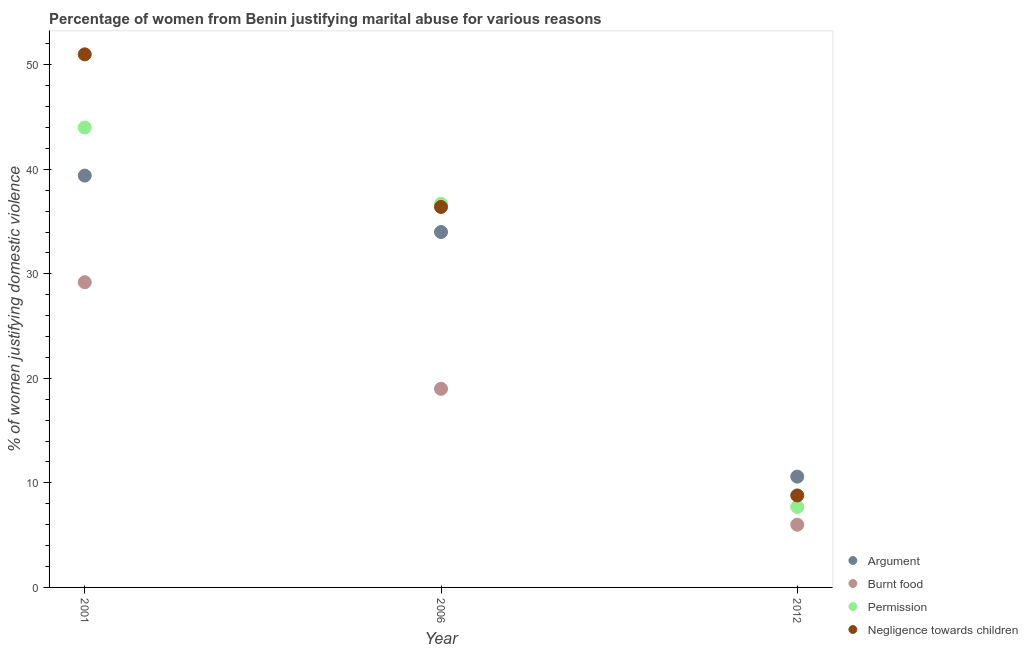Is the number of dotlines equal to the number of legend labels?
Your answer should be compact. Yes. What is the percentage of women justifying abuse for burning food in 2006?
Make the answer very short. 19. Across all years, what is the maximum percentage of women justifying abuse in the case of an argument?
Provide a succinct answer. 39.4. In which year was the percentage of women justifying abuse for going without permission maximum?
Keep it short and to the point. 2001. What is the total percentage of women justifying abuse in the case of an argument in the graph?
Ensure brevity in your answer.  84. What is the difference between the percentage of women justifying abuse in the case of an argument in 2001 and that in 2006?
Your response must be concise. 5.4. What is the difference between the percentage of women justifying abuse for showing negligence towards children in 2001 and the percentage of women justifying abuse in the case of an argument in 2012?
Give a very brief answer. 40.4. What is the average percentage of women justifying abuse for burning food per year?
Offer a very short reply. 18.07. In the year 2001, what is the difference between the percentage of women justifying abuse in the case of an argument and percentage of women justifying abuse for showing negligence towards children?
Provide a short and direct response. -11.6. What is the ratio of the percentage of women justifying abuse for going without permission in 2001 to that in 2006?
Provide a succinct answer. 1.2. What is the difference between the highest and the second highest percentage of women justifying abuse in the case of an argument?
Make the answer very short. 5.4. What is the difference between the highest and the lowest percentage of women justifying abuse for burning food?
Make the answer very short. 23.2. In how many years, is the percentage of women justifying abuse for showing negligence towards children greater than the average percentage of women justifying abuse for showing negligence towards children taken over all years?
Ensure brevity in your answer.  2. Is it the case that in every year, the sum of the percentage of women justifying abuse in the case of an argument and percentage of women justifying abuse for burning food is greater than the percentage of women justifying abuse for going without permission?
Give a very brief answer. Yes. Does the percentage of women justifying abuse for showing negligence towards children monotonically increase over the years?
Provide a succinct answer. No. Is the percentage of women justifying abuse for burning food strictly less than the percentage of women justifying abuse in the case of an argument over the years?
Give a very brief answer. Yes. How many years are there in the graph?
Make the answer very short. 3. What is the difference between two consecutive major ticks on the Y-axis?
Give a very brief answer. 10. Are the values on the major ticks of Y-axis written in scientific E-notation?
Ensure brevity in your answer.  No. How are the legend labels stacked?
Provide a succinct answer. Vertical. What is the title of the graph?
Your response must be concise. Percentage of women from Benin justifying marital abuse for various reasons. What is the label or title of the X-axis?
Offer a terse response. Year. What is the label or title of the Y-axis?
Offer a very short reply. % of women justifying domestic violence. What is the % of women justifying domestic violence in Argument in 2001?
Your response must be concise. 39.4. What is the % of women justifying domestic violence of Burnt food in 2001?
Give a very brief answer. 29.2. What is the % of women justifying domestic violence in Argument in 2006?
Offer a very short reply. 34. What is the % of women justifying domestic violence in Burnt food in 2006?
Provide a short and direct response. 19. What is the % of women justifying domestic violence of Permission in 2006?
Make the answer very short. 36.7. What is the % of women justifying domestic violence of Negligence towards children in 2006?
Ensure brevity in your answer.  36.4. Across all years, what is the maximum % of women justifying domestic violence in Argument?
Keep it short and to the point. 39.4. Across all years, what is the maximum % of women justifying domestic violence of Burnt food?
Offer a terse response. 29.2. Across all years, what is the maximum % of women justifying domestic violence of Negligence towards children?
Provide a succinct answer. 51. Across all years, what is the minimum % of women justifying domestic violence in Argument?
Keep it short and to the point. 10.6. Across all years, what is the minimum % of women justifying domestic violence of Burnt food?
Offer a very short reply. 6. Across all years, what is the minimum % of women justifying domestic violence of Negligence towards children?
Make the answer very short. 8.8. What is the total % of women justifying domestic violence in Argument in the graph?
Your response must be concise. 84. What is the total % of women justifying domestic violence in Burnt food in the graph?
Offer a terse response. 54.2. What is the total % of women justifying domestic violence of Permission in the graph?
Provide a short and direct response. 88.4. What is the total % of women justifying domestic violence of Negligence towards children in the graph?
Provide a succinct answer. 96.2. What is the difference between the % of women justifying domestic violence of Argument in 2001 and that in 2006?
Make the answer very short. 5.4. What is the difference between the % of women justifying domestic violence of Burnt food in 2001 and that in 2006?
Give a very brief answer. 10.2. What is the difference between the % of women justifying domestic violence of Permission in 2001 and that in 2006?
Ensure brevity in your answer.  7.3. What is the difference between the % of women justifying domestic violence of Argument in 2001 and that in 2012?
Make the answer very short. 28.8. What is the difference between the % of women justifying domestic violence in Burnt food in 2001 and that in 2012?
Offer a very short reply. 23.2. What is the difference between the % of women justifying domestic violence of Permission in 2001 and that in 2012?
Your response must be concise. 36.3. What is the difference between the % of women justifying domestic violence in Negligence towards children in 2001 and that in 2012?
Keep it short and to the point. 42.2. What is the difference between the % of women justifying domestic violence in Argument in 2006 and that in 2012?
Give a very brief answer. 23.4. What is the difference between the % of women justifying domestic violence of Burnt food in 2006 and that in 2012?
Your answer should be very brief. 13. What is the difference between the % of women justifying domestic violence in Negligence towards children in 2006 and that in 2012?
Ensure brevity in your answer.  27.6. What is the difference between the % of women justifying domestic violence of Argument in 2001 and the % of women justifying domestic violence of Burnt food in 2006?
Your answer should be compact. 20.4. What is the difference between the % of women justifying domestic violence of Argument in 2001 and the % of women justifying domestic violence of Negligence towards children in 2006?
Give a very brief answer. 3. What is the difference between the % of women justifying domestic violence in Argument in 2001 and the % of women justifying domestic violence in Burnt food in 2012?
Your answer should be compact. 33.4. What is the difference between the % of women justifying domestic violence in Argument in 2001 and the % of women justifying domestic violence in Permission in 2012?
Your answer should be compact. 31.7. What is the difference between the % of women justifying domestic violence in Argument in 2001 and the % of women justifying domestic violence in Negligence towards children in 2012?
Make the answer very short. 30.6. What is the difference between the % of women justifying domestic violence of Burnt food in 2001 and the % of women justifying domestic violence of Negligence towards children in 2012?
Offer a very short reply. 20.4. What is the difference between the % of women justifying domestic violence of Permission in 2001 and the % of women justifying domestic violence of Negligence towards children in 2012?
Offer a very short reply. 35.2. What is the difference between the % of women justifying domestic violence in Argument in 2006 and the % of women justifying domestic violence in Burnt food in 2012?
Ensure brevity in your answer.  28. What is the difference between the % of women justifying domestic violence in Argument in 2006 and the % of women justifying domestic violence in Permission in 2012?
Your response must be concise. 26.3. What is the difference between the % of women justifying domestic violence of Argument in 2006 and the % of women justifying domestic violence of Negligence towards children in 2012?
Your response must be concise. 25.2. What is the difference between the % of women justifying domestic violence in Burnt food in 2006 and the % of women justifying domestic violence in Permission in 2012?
Your response must be concise. 11.3. What is the difference between the % of women justifying domestic violence of Burnt food in 2006 and the % of women justifying domestic violence of Negligence towards children in 2012?
Offer a terse response. 10.2. What is the difference between the % of women justifying domestic violence of Permission in 2006 and the % of women justifying domestic violence of Negligence towards children in 2012?
Keep it short and to the point. 27.9. What is the average % of women justifying domestic violence in Argument per year?
Provide a succinct answer. 28. What is the average % of women justifying domestic violence in Burnt food per year?
Provide a succinct answer. 18.07. What is the average % of women justifying domestic violence in Permission per year?
Give a very brief answer. 29.47. What is the average % of women justifying domestic violence in Negligence towards children per year?
Offer a terse response. 32.07. In the year 2001, what is the difference between the % of women justifying domestic violence in Argument and % of women justifying domestic violence in Burnt food?
Give a very brief answer. 10.2. In the year 2001, what is the difference between the % of women justifying domestic violence of Argument and % of women justifying domestic violence of Permission?
Keep it short and to the point. -4.6. In the year 2001, what is the difference between the % of women justifying domestic violence in Burnt food and % of women justifying domestic violence in Permission?
Give a very brief answer. -14.8. In the year 2001, what is the difference between the % of women justifying domestic violence in Burnt food and % of women justifying domestic violence in Negligence towards children?
Make the answer very short. -21.8. In the year 2006, what is the difference between the % of women justifying domestic violence in Argument and % of women justifying domestic violence in Negligence towards children?
Offer a terse response. -2.4. In the year 2006, what is the difference between the % of women justifying domestic violence in Burnt food and % of women justifying domestic violence in Permission?
Keep it short and to the point. -17.7. In the year 2006, what is the difference between the % of women justifying domestic violence of Burnt food and % of women justifying domestic violence of Negligence towards children?
Your response must be concise. -17.4. In the year 2006, what is the difference between the % of women justifying domestic violence in Permission and % of women justifying domestic violence in Negligence towards children?
Keep it short and to the point. 0.3. In the year 2012, what is the difference between the % of women justifying domestic violence in Argument and % of women justifying domestic violence in Burnt food?
Keep it short and to the point. 4.6. In the year 2012, what is the difference between the % of women justifying domestic violence of Argument and % of women justifying domestic violence of Negligence towards children?
Your response must be concise. 1.8. In the year 2012, what is the difference between the % of women justifying domestic violence of Permission and % of women justifying domestic violence of Negligence towards children?
Your response must be concise. -1.1. What is the ratio of the % of women justifying domestic violence of Argument in 2001 to that in 2006?
Provide a short and direct response. 1.16. What is the ratio of the % of women justifying domestic violence in Burnt food in 2001 to that in 2006?
Provide a short and direct response. 1.54. What is the ratio of the % of women justifying domestic violence of Permission in 2001 to that in 2006?
Provide a succinct answer. 1.2. What is the ratio of the % of women justifying domestic violence in Negligence towards children in 2001 to that in 2006?
Give a very brief answer. 1.4. What is the ratio of the % of women justifying domestic violence of Argument in 2001 to that in 2012?
Provide a succinct answer. 3.72. What is the ratio of the % of women justifying domestic violence of Burnt food in 2001 to that in 2012?
Provide a short and direct response. 4.87. What is the ratio of the % of women justifying domestic violence of Permission in 2001 to that in 2012?
Keep it short and to the point. 5.71. What is the ratio of the % of women justifying domestic violence of Negligence towards children in 2001 to that in 2012?
Make the answer very short. 5.8. What is the ratio of the % of women justifying domestic violence in Argument in 2006 to that in 2012?
Ensure brevity in your answer.  3.21. What is the ratio of the % of women justifying domestic violence of Burnt food in 2006 to that in 2012?
Your response must be concise. 3.17. What is the ratio of the % of women justifying domestic violence in Permission in 2006 to that in 2012?
Ensure brevity in your answer.  4.77. What is the ratio of the % of women justifying domestic violence in Negligence towards children in 2006 to that in 2012?
Offer a very short reply. 4.14. What is the difference between the highest and the second highest % of women justifying domestic violence in Burnt food?
Ensure brevity in your answer.  10.2. What is the difference between the highest and the lowest % of women justifying domestic violence in Argument?
Offer a very short reply. 28.8. What is the difference between the highest and the lowest % of women justifying domestic violence in Burnt food?
Offer a very short reply. 23.2. What is the difference between the highest and the lowest % of women justifying domestic violence in Permission?
Provide a succinct answer. 36.3. What is the difference between the highest and the lowest % of women justifying domestic violence of Negligence towards children?
Your answer should be very brief. 42.2. 